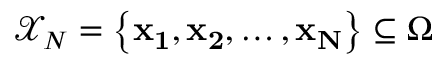<formula> <loc_0><loc_0><loc_500><loc_500>\mathcal { X } _ { N } = \left \{ x _ { 1 } , x _ { 2 } , \dots c , x _ { N } \right \} \subseteq \Omega</formula> 